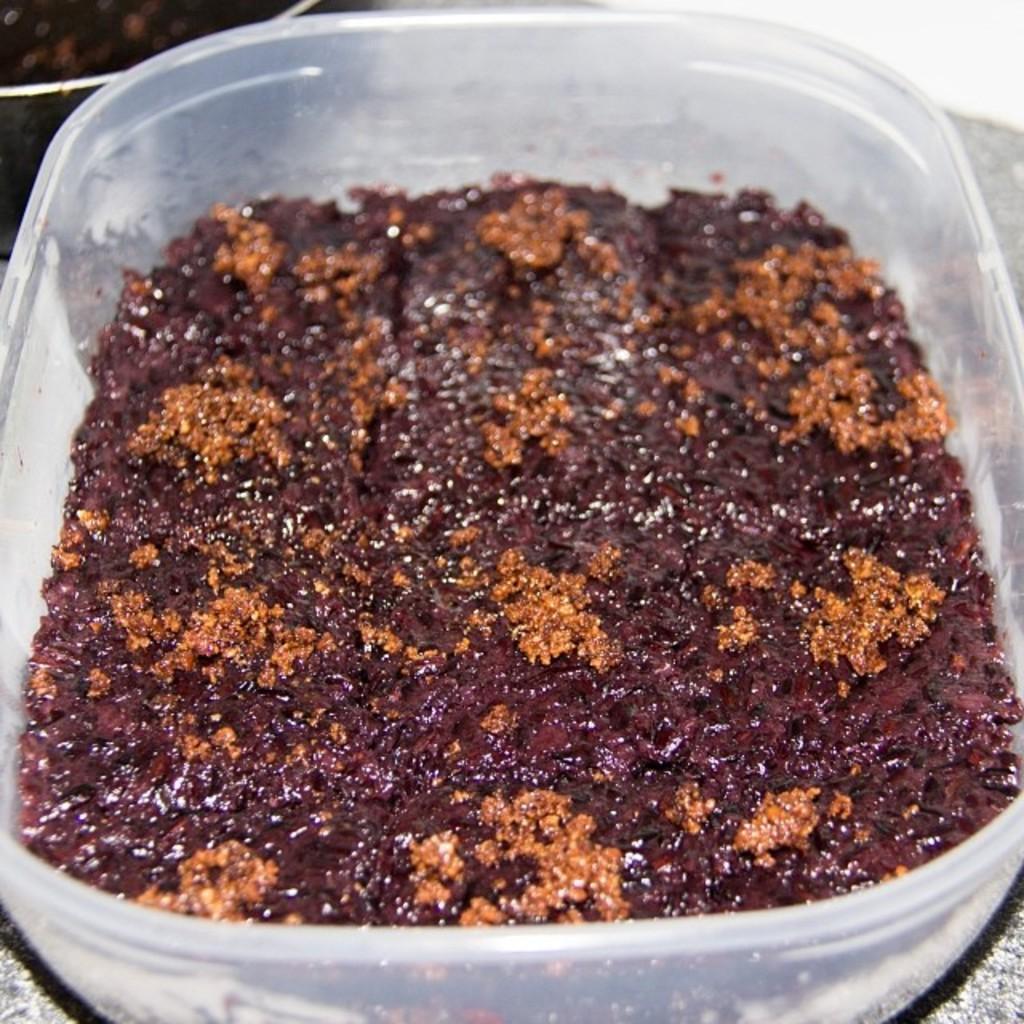Please provide a concise description of this image. In this picture I can see food item in the plastic box. 